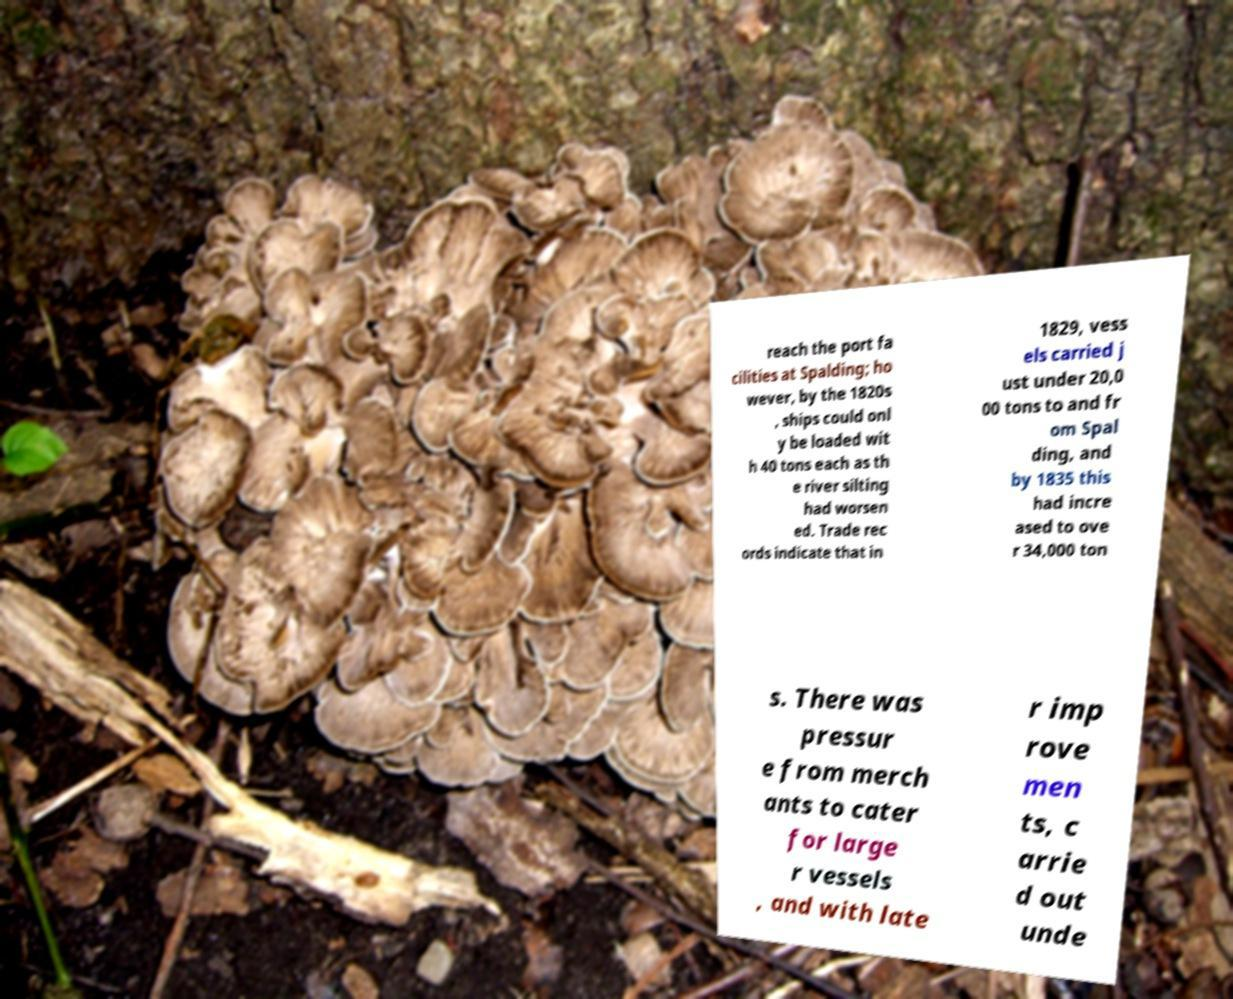Could you assist in decoding the text presented in this image and type it out clearly? reach the port fa cilities at Spalding; ho wever, by the 1820s , ships could onl y be loaded wit h 40 tons each as th e river silting had worsen ed. Trade rec ords indicate that in 1829, vess els carried j ust under 20,0 00 tons to and fr om Spal ding, and by 1835 this had incre ased to ove r 34,000 ton s. There was pressur e from merch ants to cater for large r vessels , and with late r imp rove men ts, c arrie d out unde 